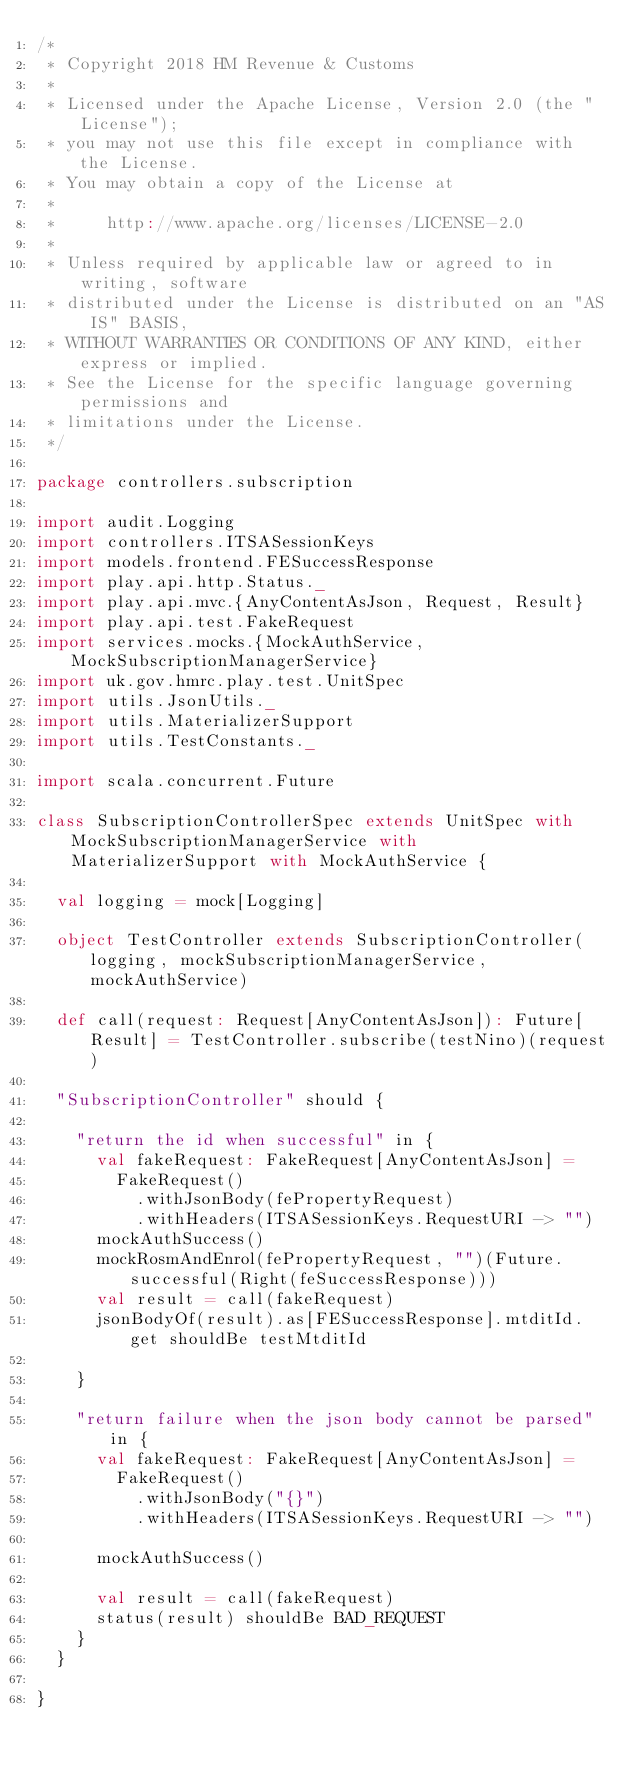<code> <loc_0><loc_0><loc_500><loc_500><_Scala_>/*
 * Copyright 2018 HM Revenue & Customs
 *
 * Licensed under the Apache License, Version 2.0 (the "License");
 * you may not use this file except in compliance with the License.
 * You may obtain a copy of the License at
 *
 *     http://www.apache.org/licenses/LICENSE-2.0
 *
 * Unless required by applicable law or agreed to in writing, software
 * distributed under the License is distributed on an "AS IS" BASIS,
 * WITHOUT WARRANTIES OR CONDITIONS OF ANY KIND, either express or implied.
 * See the License for the specific language governing permissions and
 * limitations under the License.
 */

package controllers.subscription

import audit.Logging
import controllers.ITSASessionKeys
import models.frontend.FESuccessResponse
import play.api.http.Status._
import play.api.mvc.{AnyContentAsJson, Request, Result}
import play.api.test.FakeRequest
import services.mocks.{MockAuthService, MockSubscriptionManagerService}
import uk.gov.hmrc.play.test.UnitSpec
import utils.JsonUtils._
import utils.MaterializerSupport
import utils.TestConstants._

import scala.concurrent.Future

class SubscriptionControllerSpec extends UnitSpec with MockSubscriptionManagerService with MaterializerSupport with MockAuthService {

  val logging = mock[Logging]

  object TestController extends SubscriptionController(logging, mockSubscriptionManagerService, mockAuthService)

  def call(request: Request[AnyContentAsJson]): Future[Result] = TestController.subscribe(testNino)(request)

  "SubscriptionController" should {

    "return the id when successful" in {
      val fakeRequest: FakeRequest[AnyContentAsJson] =
        FakeRequest()
          .withJsonBody(fePropertyRequest)
          .withHeaders(ITSASessionKeys.RequestURI -> "")
      mockAuthSuccess()
      mockRosmAndEnrol(fePropertyRequest, "")(Future.successful(Right(feSuccessResponse)))
      val result = call(fakeRequest)
      jsonBodyOf(result).as[FESuccessResponse].mtditId.get shouldBe testMtditId

    }

    "return failure when the json body cannot be parsed" in {
      val fakeRequest: FakeRequest[AnyContentAsJson] =
        FakeRequest()
          .withJsonBody("{}")
          .withHeaders(ITSASessionKeys.RequestURI -> "")

      mockAuthSuccess()

      val result = call(fakeRequest)
      status(result) shouldBe BAD_REQUEST
    }
  }

}
</code> 